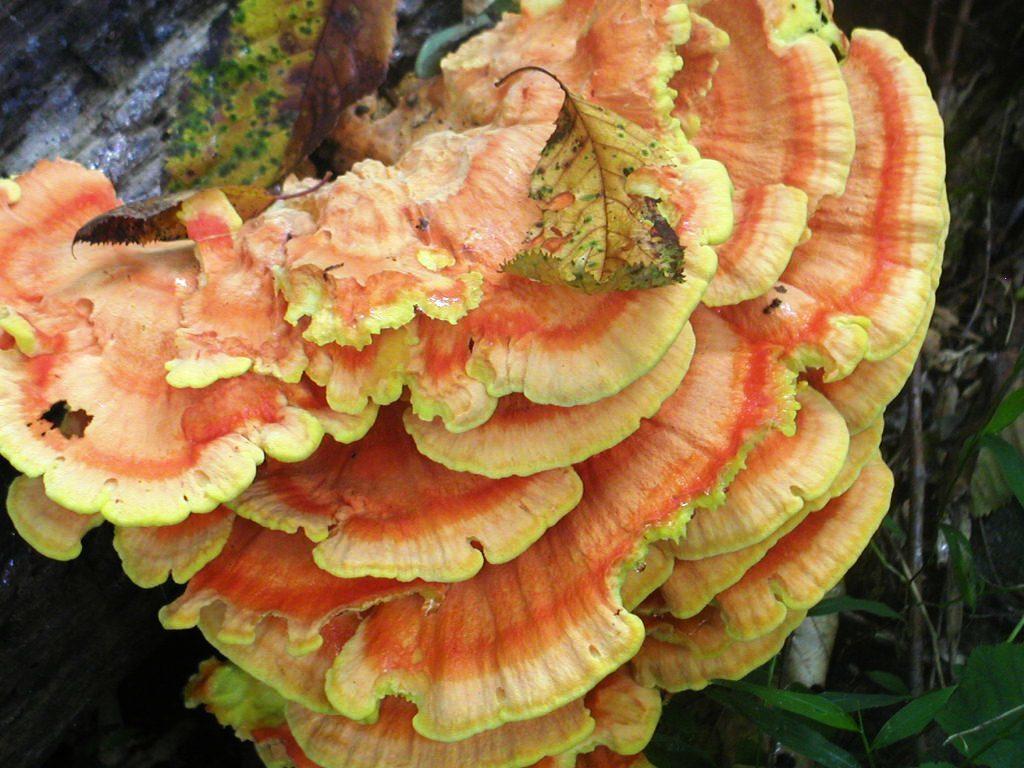Describe this image in one or two sentences. In the picture there is a yellow and pink color mushroom and beside the mushroom there are some leaves. 